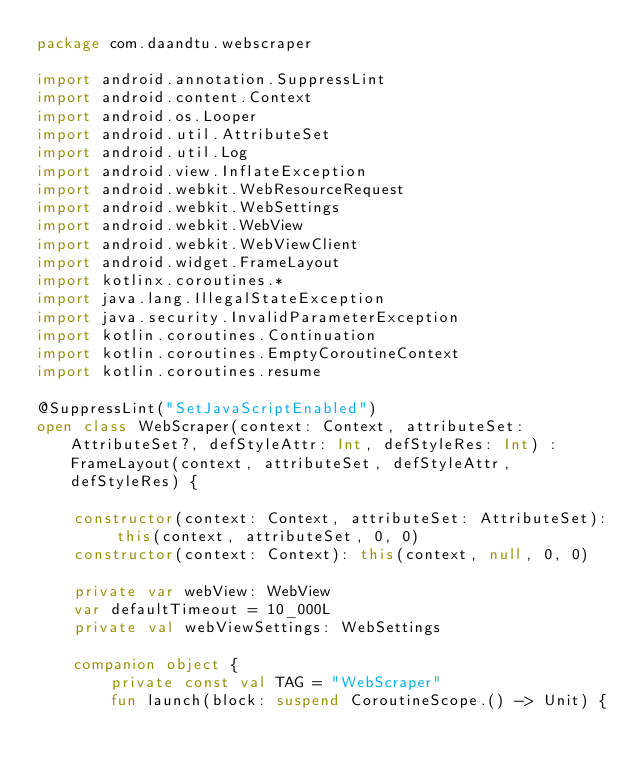<code> <loc_0><loc_0><loc_500><loc_500><_Kotlin_>package com.daandtu.webscraper

import android.annotation.SuppressLint
import android.content.Context
import android.os.Looper
import android.util.AttributeSet
import android.util.Log
import android.view.InflateException
import android.webkit.WebResourceRequest
import android.webkit.WebSettings
import android.webkit.WebView
import android.webkit.WebViewClient
import android.widget.FrameLayout
import kotlinx.coroutines.*
import java.lang.IllegalStateException
import java.security.InvalidParameterException
import kotlin.coroutines.Continuation
import kotlin.coroutines.EmptyCoroutineContext
import kotlin.coroutines.resume

@SuppressLint("SetJavaScriptEnabled")
open class WebScraper(context: Context, attributeSet: AttributeSet?, defStyleAttr: Int, defStyleRes: Int) : FrameLayout(context, attributeSet, defStyleAttr, defStyleRes) {

    constructor(context: Context, attributeSet: AttributeSet): this(context, attributeSet, 0, 0)
    constructor(context: Context): this(context, null, 0, 0)

    private var webView: WebView
    var defaultTimeout = 10_000L
    private val webViewSettings: WebSettings

    companion object {
        private const val TAG = "WebScraper"
        fun launch(block: suspend CoroutineScope.() -> Unit) {</code> 